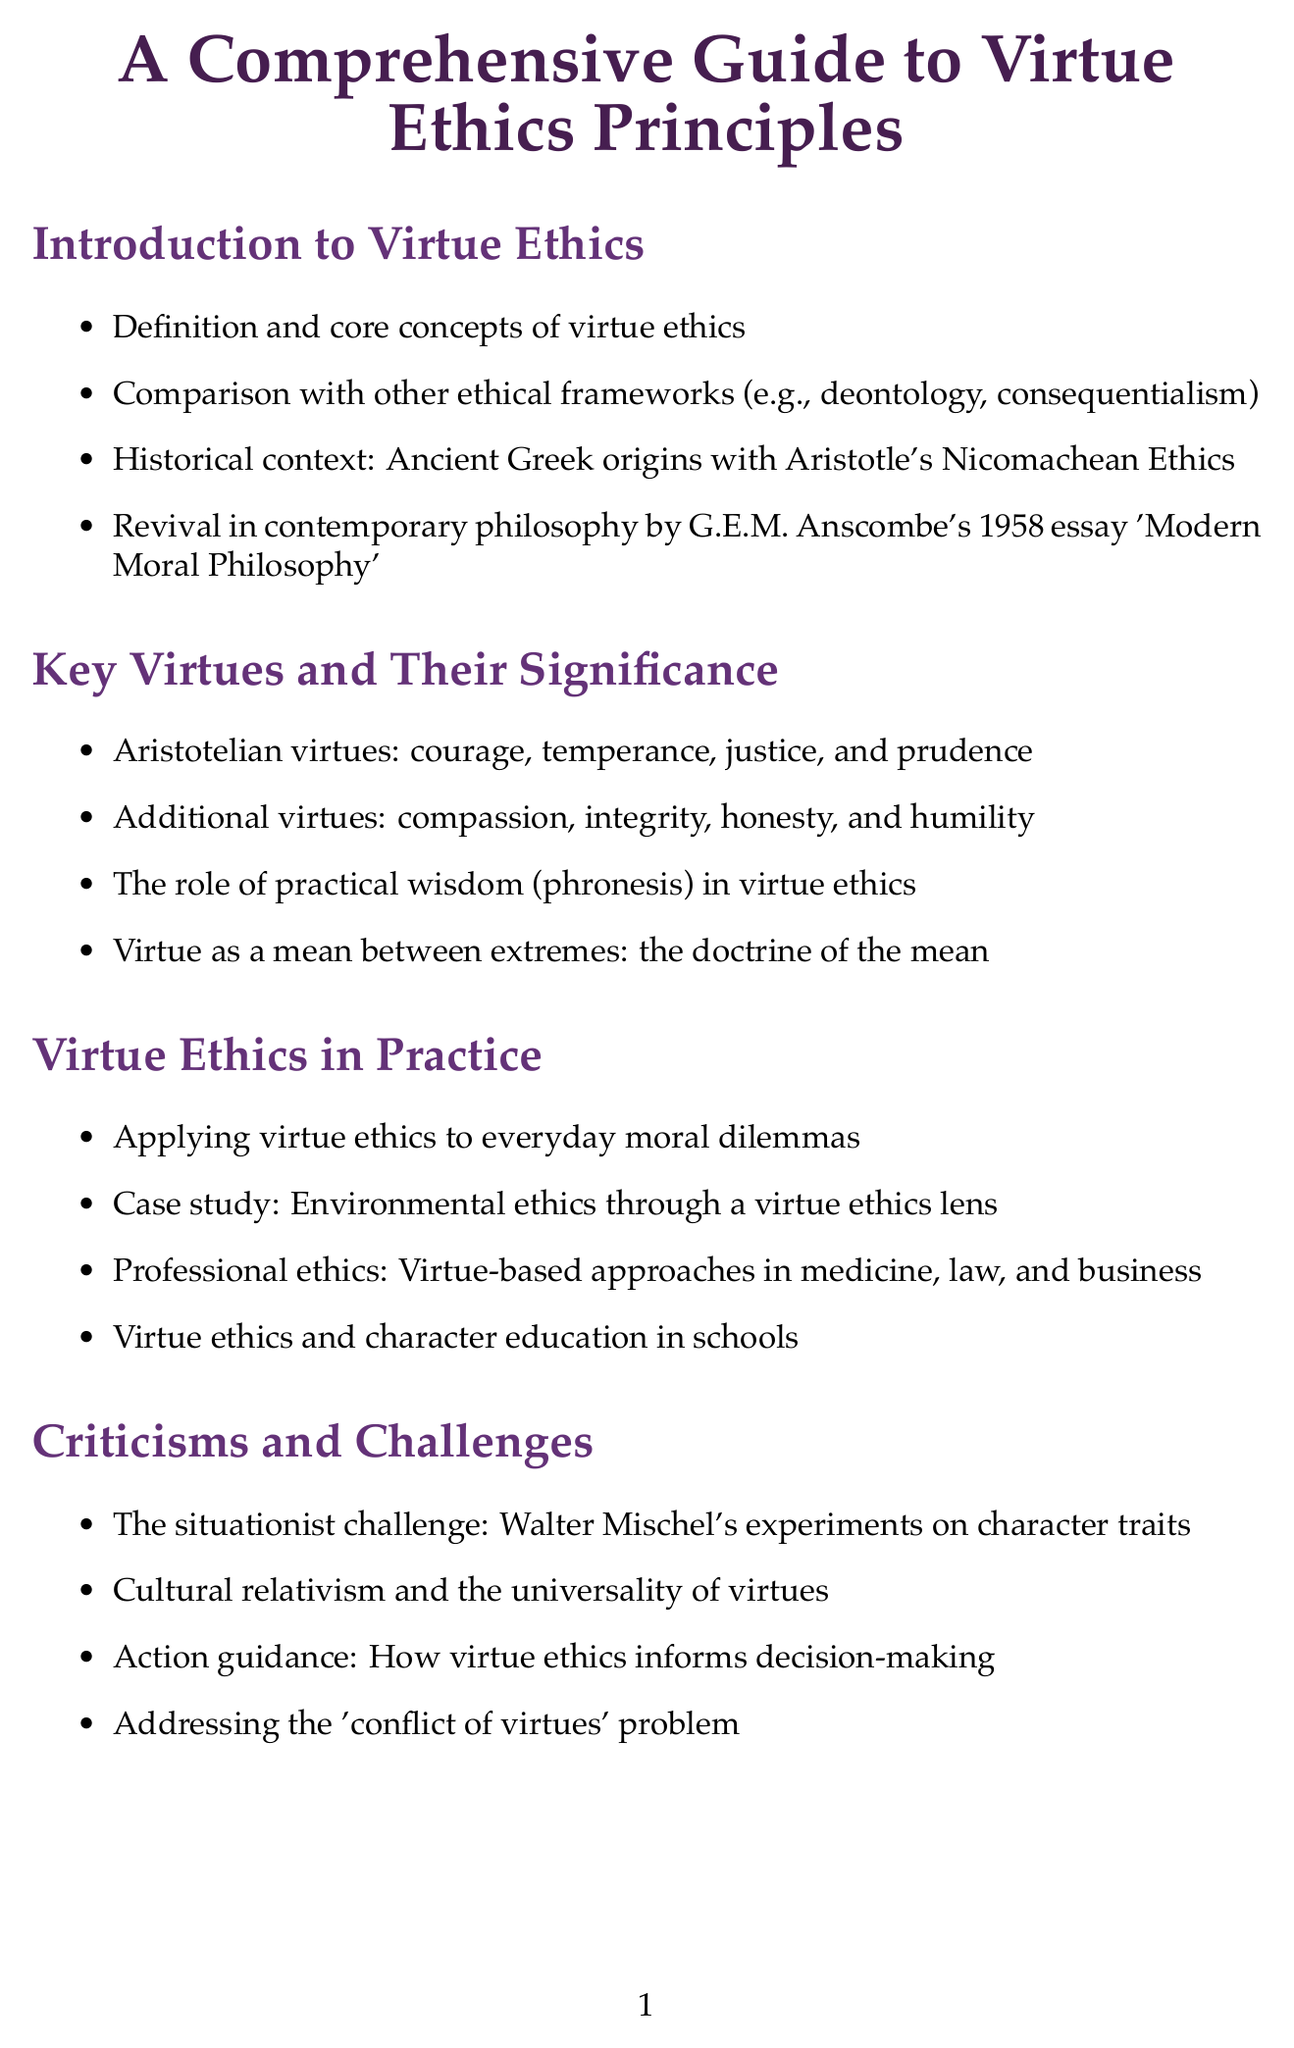What is the title of the document? The title is presented at the beginning of the document and clearly states the subject matter.
Answer: A Comprehensive Guide to Virtue Ethics Principles Who is a notable philosopher mentioned in the document? The document lists several notable philosophers, highlighting their contributions to virtue ethics.
Answer: Aristotle What year was G.E.M. Anscombe's significant essay published? The document mentions the year when Anscombe's essay contributed to the revival of virtue ethics.
Answer: 1958 What are the four Aristotelian virtues listed in the document? The document specifies the key Aristotelian virtues that serve as foundational concepts in virtue ethics.
Answer: courage, temperance, justice, and prudence What is the central concept linking virtue and practical wisdom? The document discusses a particular term that encompasses the role of practical wisdom in virtue ethics.
Answer: phronesis What is one challenge to virtue ethics identified in the document? The document outlines various criticisms of virtue ethics, including some specific challenges faced by this ethical framework.
Answer: The situationist challenge Which ethical approach is closely associated with Nel Noddings? The document references an important philosopher's work that is complementary to virtue ethics.
Answer: ethics of care Name one case study mentioned in the document related to virtue ethics. The document provides examples of how virtue ethics can be applied through various case studies.
Answer: Environmental ethics through a virtue ethics lens What is the concept of akhlaq related to? The document describes a significant aspect of Islamic philosophy concerning ethics.
Answer: Islamic virtue ethics 